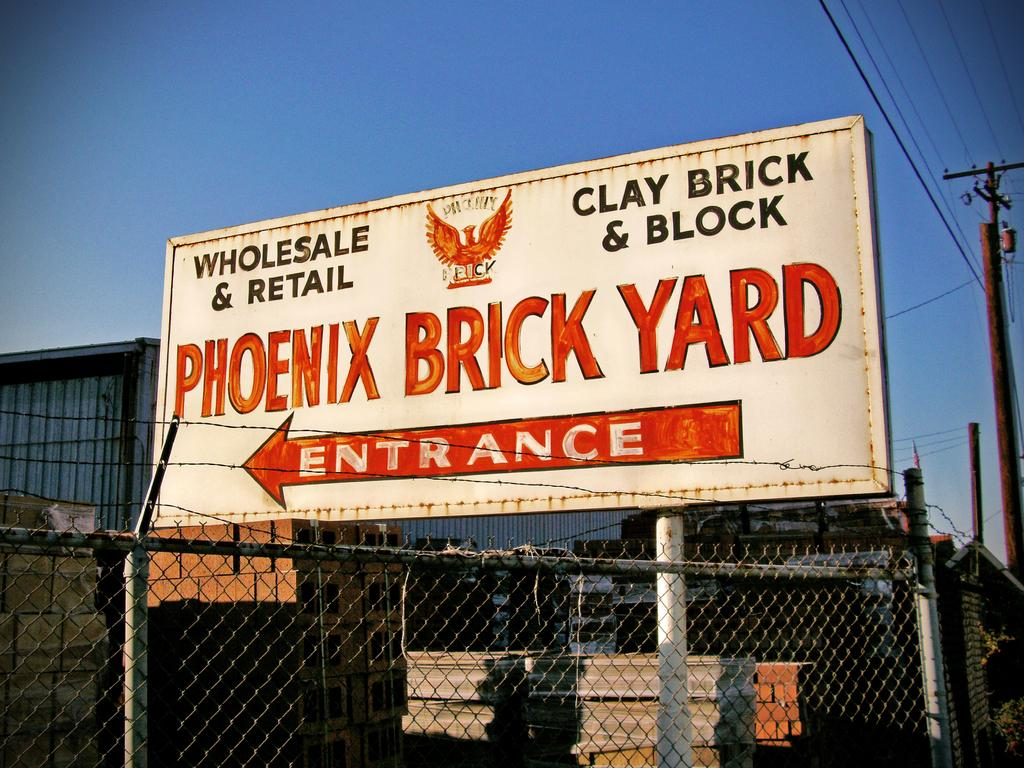<image>
Describe the image concisely. A large sign sits outside from the Phoenix Brick Yard 